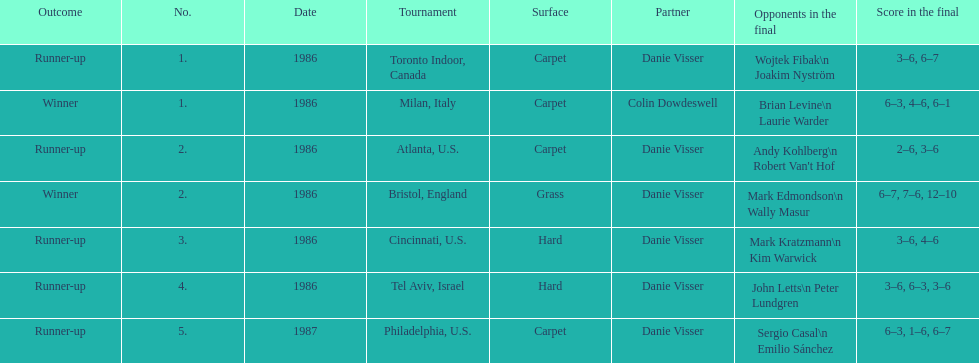Who is the last partner listed? Danie Visser. 